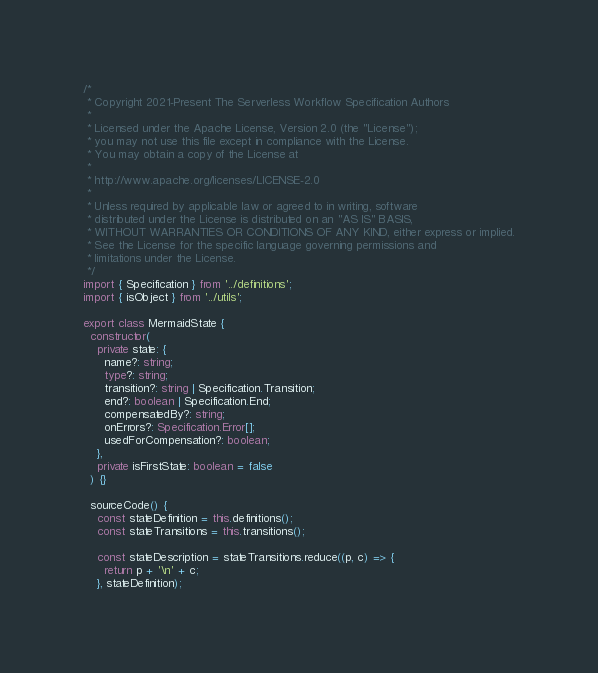Convert code to text. <code><loc_0><loc_0><loc_500><loc_500><_TypeScript_>/*
 * Copyright 2021-Present The Serverless Workflow Specification Authors
 *
 * Licensed under the Apache License, Version 2.0 (the "License");
 * you may not use this file except in compliance with the License.
 * You may obtain a copy of the License at
 *
 * http://www.apache.org/licenses/LICENSE-2.0
 *
 * Unless required by applicable law or agreed to in writing, software
 * distributed under the License is distributed on an "AS IS" BASIS,
 * WITHOUT WARRANTIES OR CONDITIONS OF ANY KIND, either express or implied.
 * See the License for the specific language governing permissions and
 * limitations under the License.
 */
import { Specification } from '../definitions';
import { isObject } from '../utils';

export class MermaidState {
  constructor(
    private state: {
      name?: string;
      type?: string;
      transition?: string | Specification.Transition;
      end?: boolean | Specification.End;
      compensatedBy?: string;
      onErrors?: Specification.Error[];
      usedForCompensation?: boolean;
    },
    private isFirstState: boolean = false
  ) {}

  sourceCode() {
    const stateDefinition = this.definitions();
    const stateTransitions = this.transitions();

    const stateDescription = stateTransitions.reduce((p, c) => {
      return p + '\n' + c;
    }, stateDefinition);
</code> 